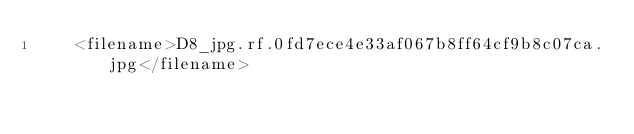<code> <loc_0><loc_0><loc_500><loc_500><_XML_>	<filename>D8_jpg.rf.0fd7ece4e33af067b8ff64cf9b8c07ca.jpg</filename></code> 